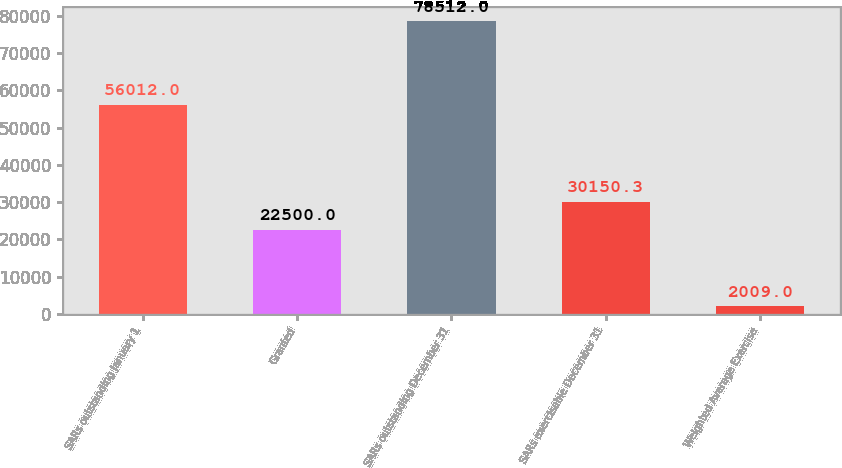<chart> <loc_0><loc_0><loc_500><loc_500><bar_chart><fcel>SARs outstanding January 1<fcel>Granted<fcel>SARs outstanding December 31<fcel>SARs exercisable December 31<fcel>Weighted Average Exercise<nl><fcel>56012<fcel>22500<fcel>78512<fcel>30150.3<fcel>2009<nl></chart> 